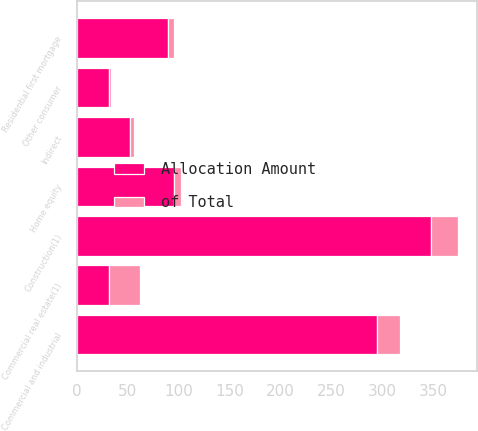Convert chart to OTSL. <chart><loc_0><loc_0><loc_500><loc_500><stacked_bar_chart><ecel><fcel>Commercial and industrial<fcel>Commercial real estate(1)<fcel>Construction(1)<fcel>Residential first mortgage<fcel>Home equity<fcel>Indirect<fcel>Other consumer<nl><fcel>Allocation Amount<fcel>295<fcel>31<fcel>348<fcel>89<fcel>95<fcel>52<fcel>31<nl><fcel>of Total<fcel>22.3<fcel>31.1<fcel>26.4<fcel>6.7<fcel>7.2<fcel>3.9<fcel>2.4<nl></chart> 